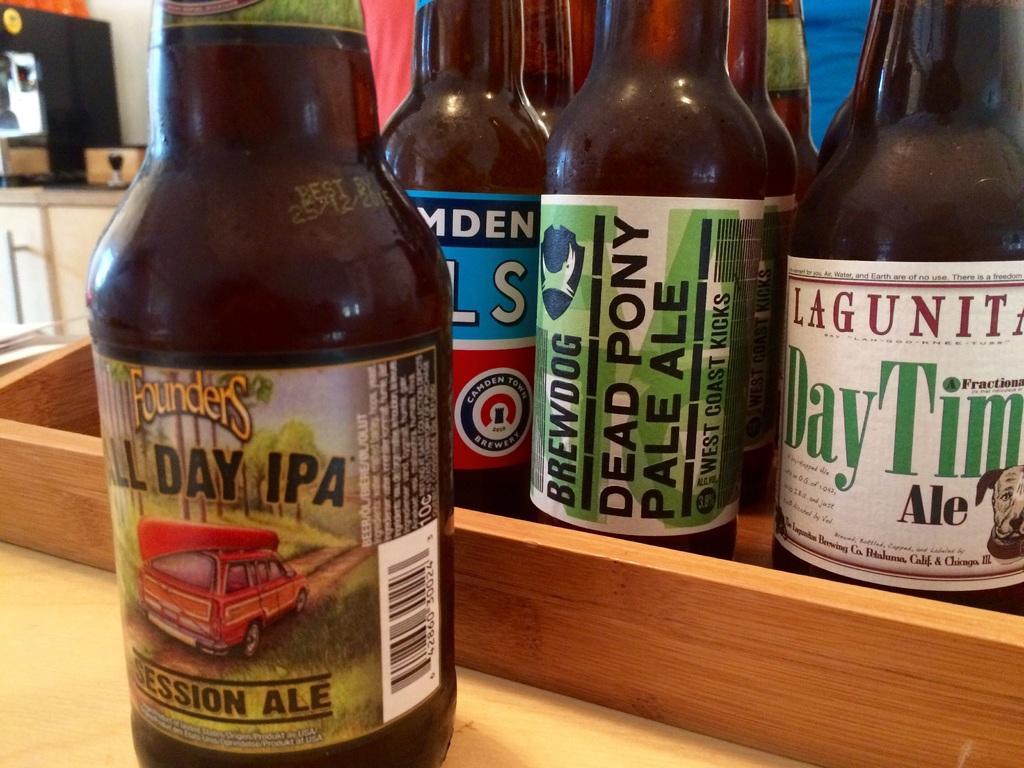<image>
Give a short and clear explanation of the subsequent image. A bottle of Founders All Day IPA sits in front of a tray holding several more beer bottles. 